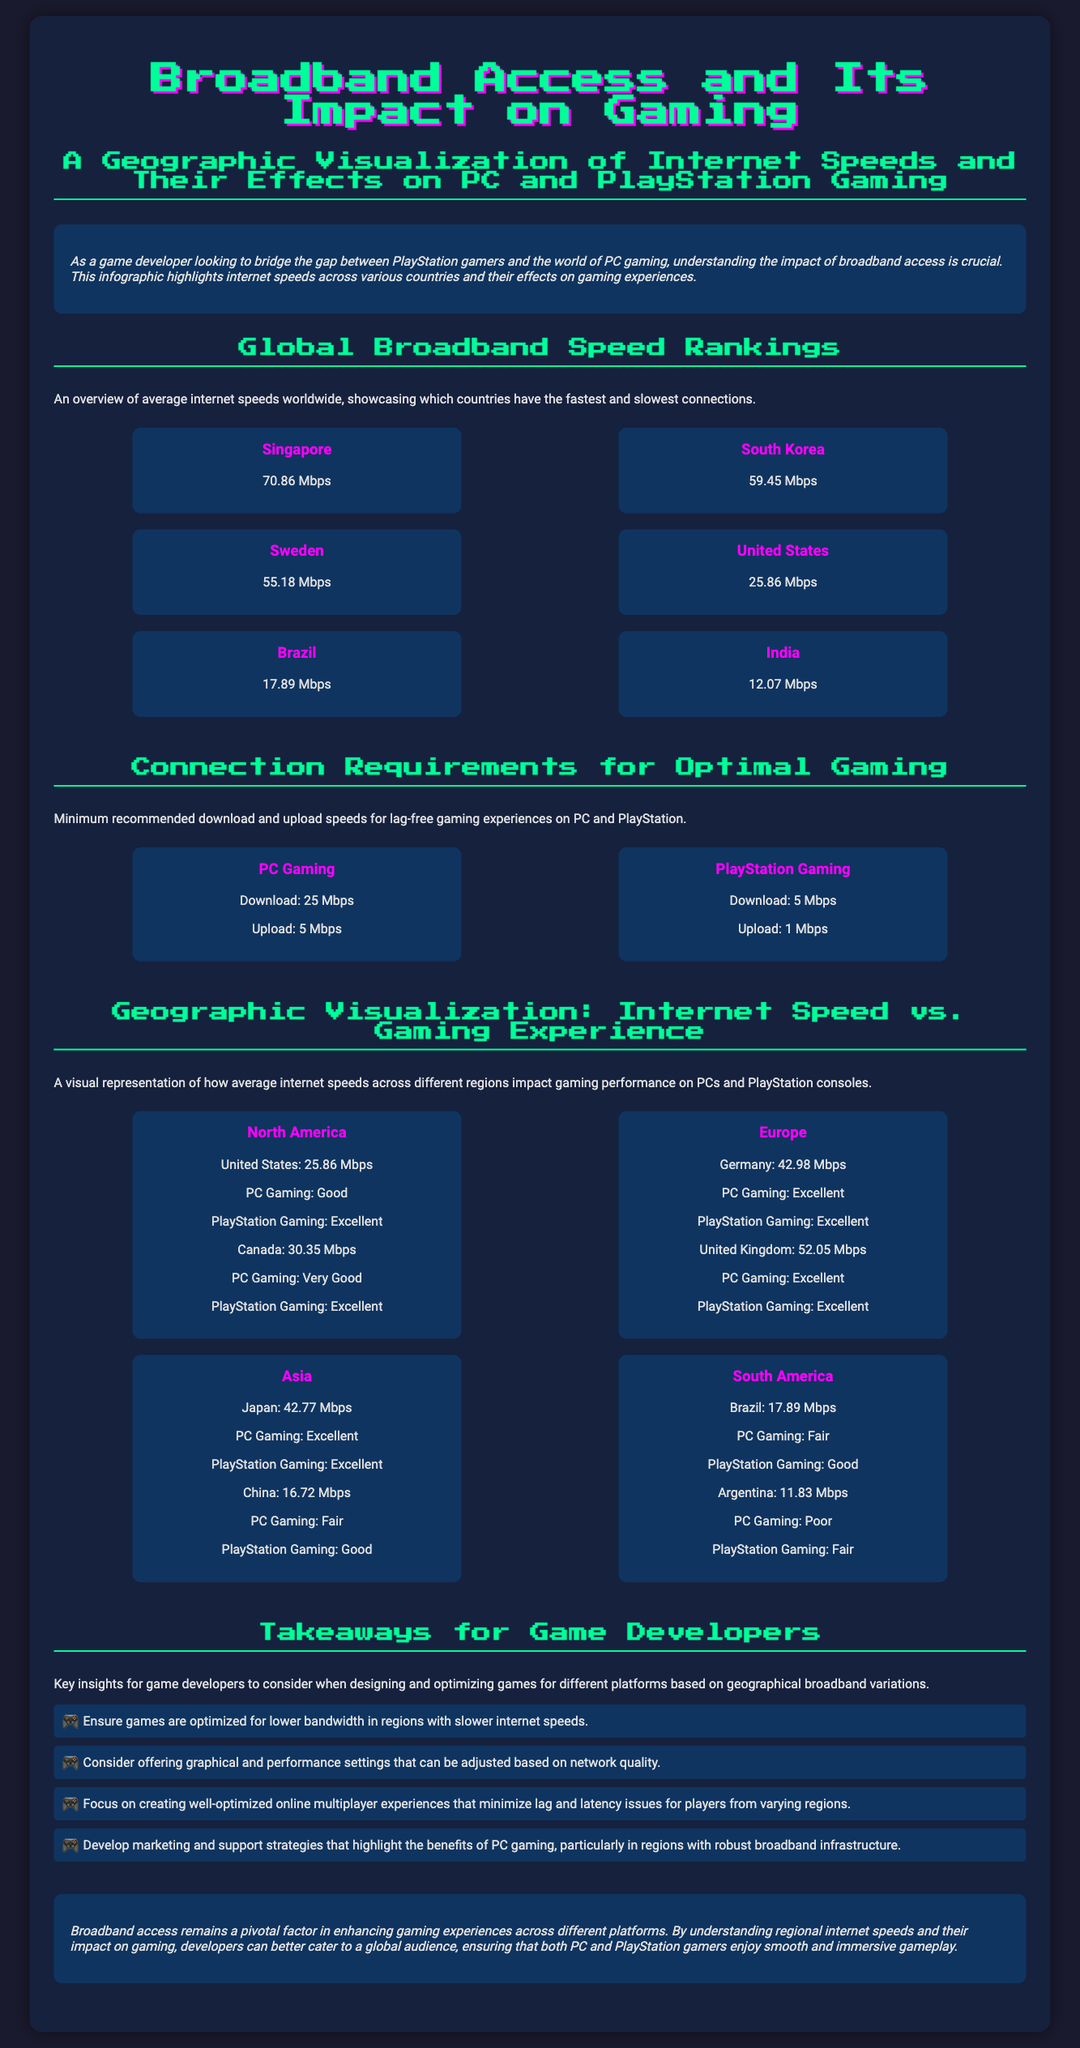What is the average internet speed in Singapore? The average internet speed in Singapore is listed as 70.86 Mbps in the Global Broadband Speed Rankings section.
Answer: 70.86 Mbps What is the minimum download speed required for PC gaming? The document states that the minimum recommended download speed for PC gaming is 25 Mbps in the Connection Requirements section.
Answer: 25 Mbps Which region has the highest internet speed for PlayStation gaming? The document provides information that North America features excellent PlayStation gaming experiences.
Answer: North America What is the average internet speed in Brazil? The average internet speed in Brazil is stated as 17.89 Mbps in the Global Broadband Speed Rankings section.
Answer: 17.89 Mbps What is the upload speed requirement for PlayStation gaming? The document specifies that the minimum upload speed required for PlayStation gaming is 1 Mbps in the Connection Requirements section.
Answer: 1 Mbps How does PC gaming in Canada compare to that in the United States? The comparison indicates that PC gaming in Canada is rated as Very Good at 30.35 Mbps, whereas in the United States, it is rated as Good at 25.86 Mbps.
Answer: Canada is Very Good, United States is Good Which country has the second-fastest internet speed? The infographic indicates that South Korea has the second-fastest internet speed at 59.45 Mbps in the Global Broadband Speed Rankings section.
Answer: South Korea What key aspect should developers consider in regions with lower bandwidth? The document highlights that developers should optimize games for lower bandwidth in regions with slower internet speeds.
Answer: Optimize for lower bandwidth What performance setting should developers focus on for online multiplayer? The takeaway suggests that developers should focus on creating well-optimized online multiplayer experiences that minimize lag and latency.
Answer: Minimize lag and latency 